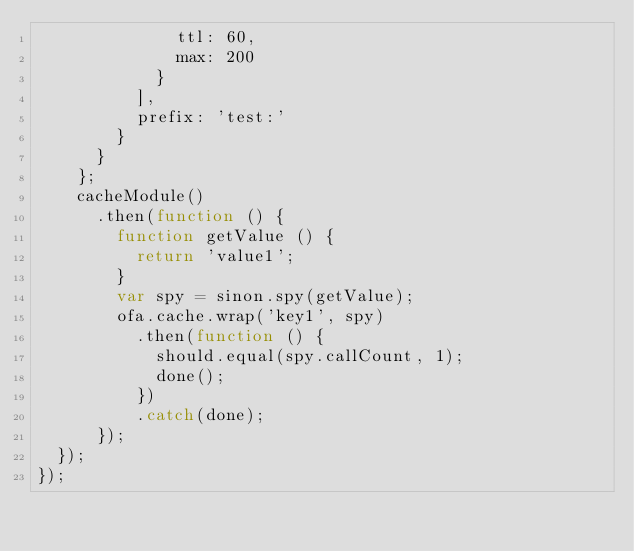Convert code to text. <code><loc_0><loc_0><loc_500><loc_500><_JavaScript_>              ttl: 60,
              max: 200
            }
          ],
          prefix: 'test:'
        }
      }
    };
    cacheModule()
      .then(function () {
        function getValue () {
          return 'value1';
        }
        var spy = sinon.spy(getValue);
        ofa.cache.wrap('key1', spy)
          .then(function () {
            should.equal(spy.callCount, 1);
            done();
          })
          .catch(done);
      });
  });
});
</code> 